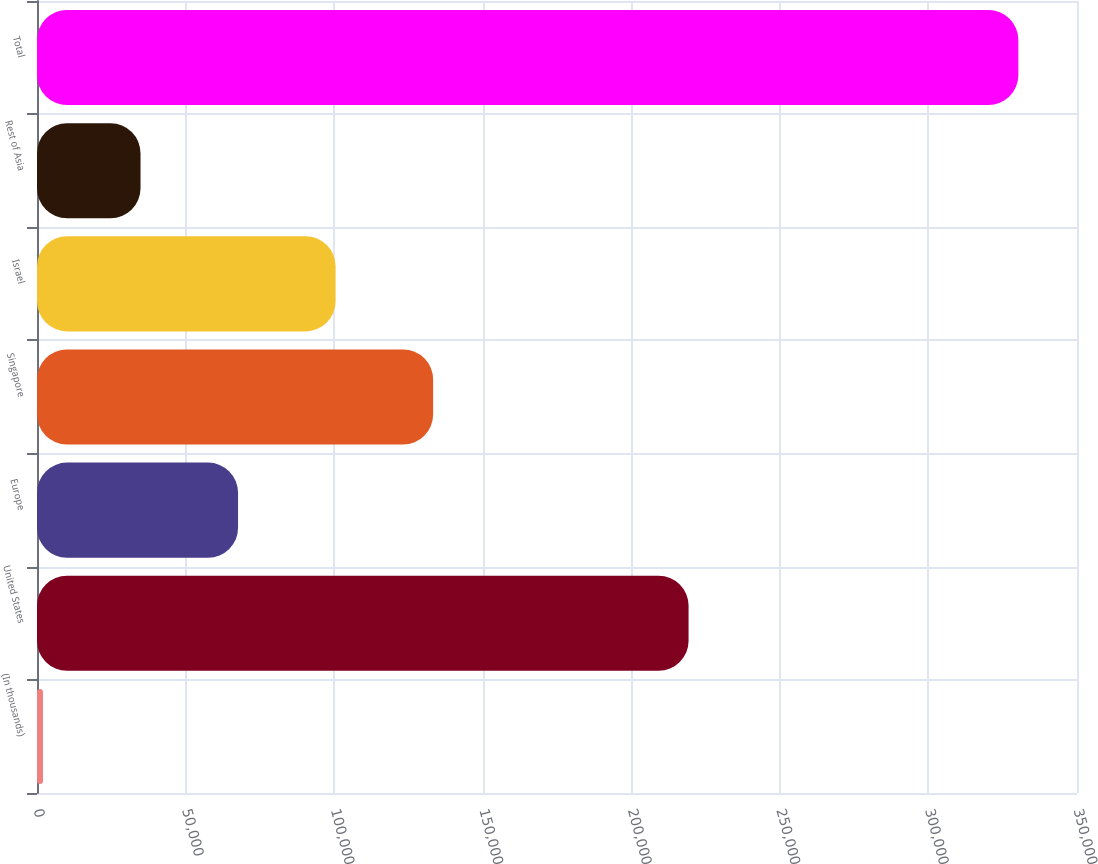Convert chart. <chart><loc_0><loc_0><loc_500><loc_500><bar_chart><fcel>(In thousands)<fcel>United States<fcel>Europe<fcel>Singapore<fcel>Israel<fcel>Rest of Asia<fcel>Total<nl><fcel>2014<fcel>219280<fcel>67663.8<fcel>133314<fcel>100489<fcel>34838.9<fcel>330263<nl></chart> 